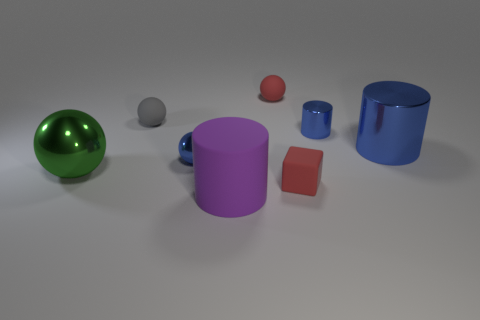Add 1 tiny red rubber blocks. How many objects exist? 9 Subtract all cylinders. How many objects are left? 5 Subtract 0 purple balls. How many objects are left? 8 Subtract all small rubber balls. Subtract all big blue metal objects. How many objects are left? 5 Add 1 large shiny cylinders. How many large shiny cylinders are left? 2 Add 5 purple matte cylinders. How many purple matte cylinders exist? 6 